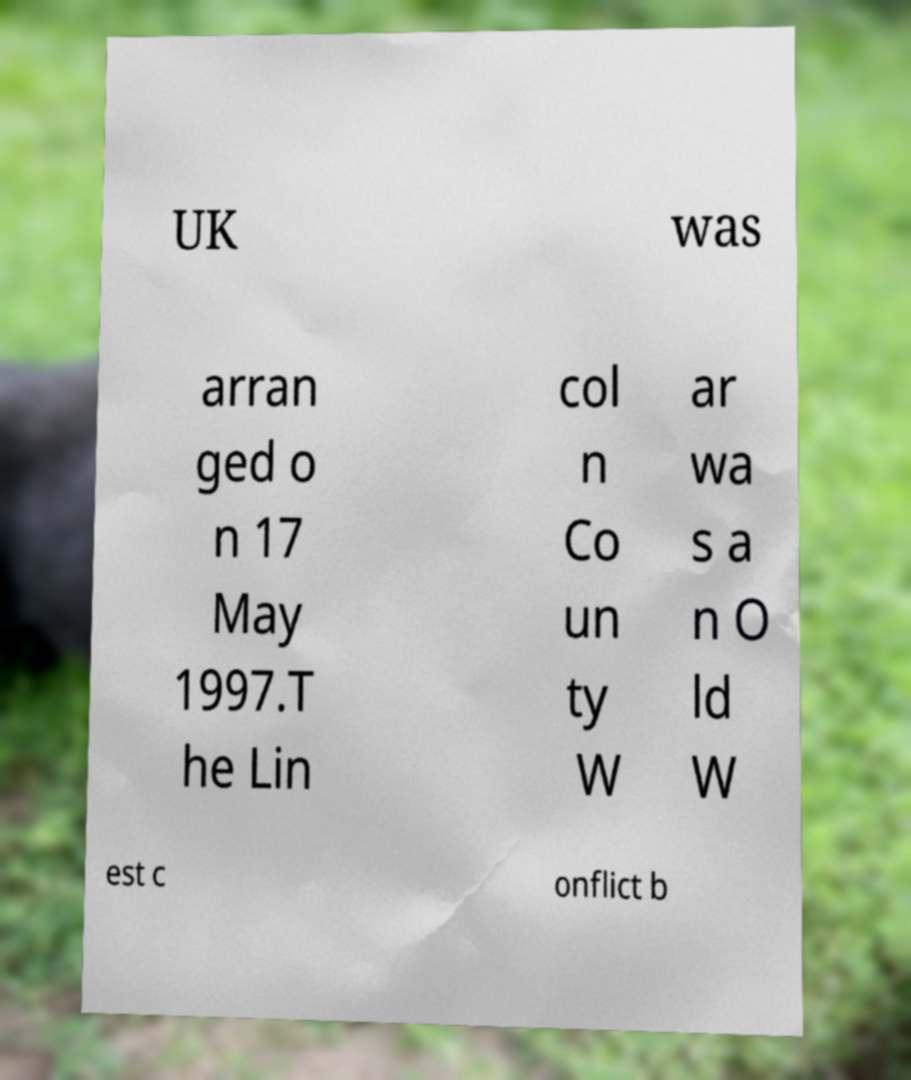I need the written content from this picture converted into text. Can you do that? UK was arran ged o n 17 May 1997.T he Lin col n Co un ty W ar wa s a n O ld W est c onflict b 